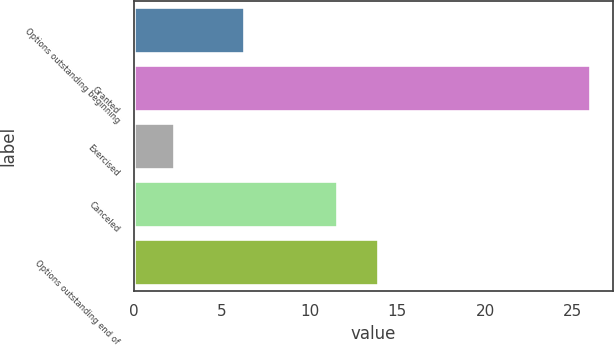<chart> <loc_0><loc_0><loc_500><loc_500><bar_chart><fcel>Options outstanding beginning<fcel>Granted<fcel>Exercised<fcel>Canceled<fcel>Options outstanding end of<nl><fcel>6.25<fcel>26<fcel>2.25<fcel>11.54<fcel>13.91<nl></chart> 